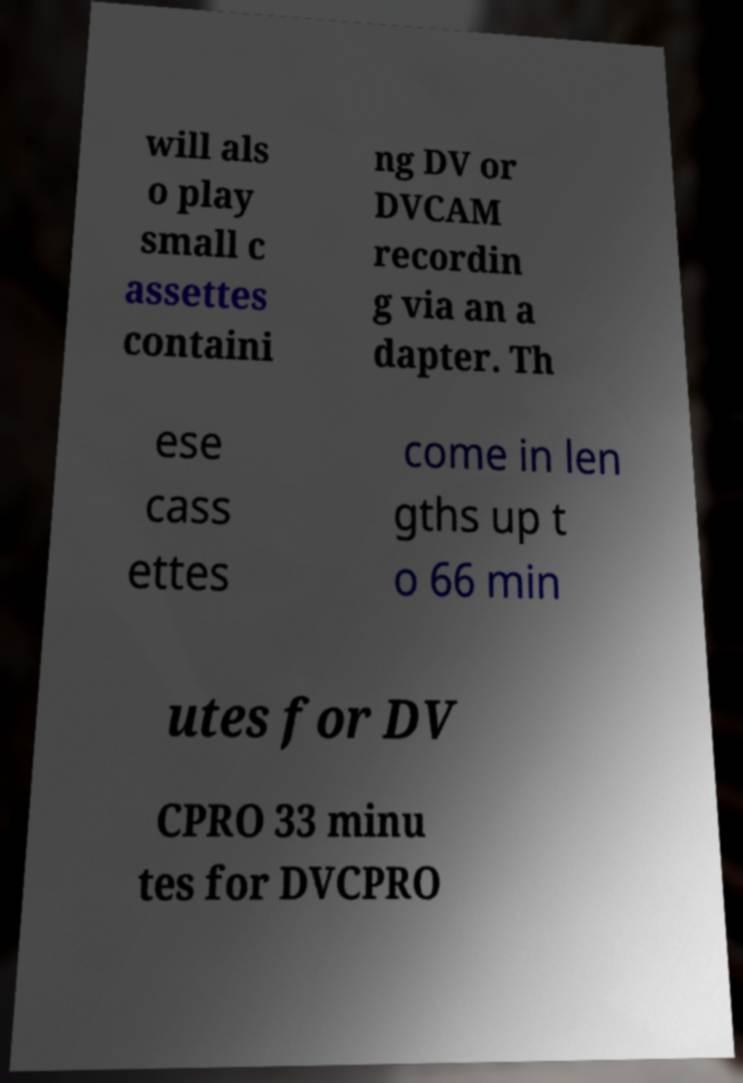What messages or text are displayed in this image? I need them in a readable, typed format. will als o play small c assettes containi ng DV or DVCAM recordin g via an a dapter. Th ese cass ettes come in len gths up t o 66 min utes for DV CPRO 33 minu tes for DVCPRO 